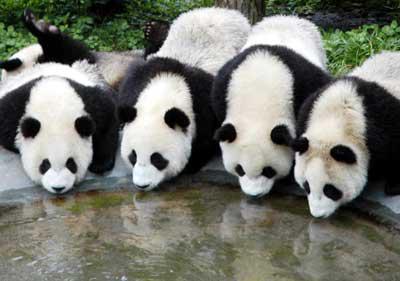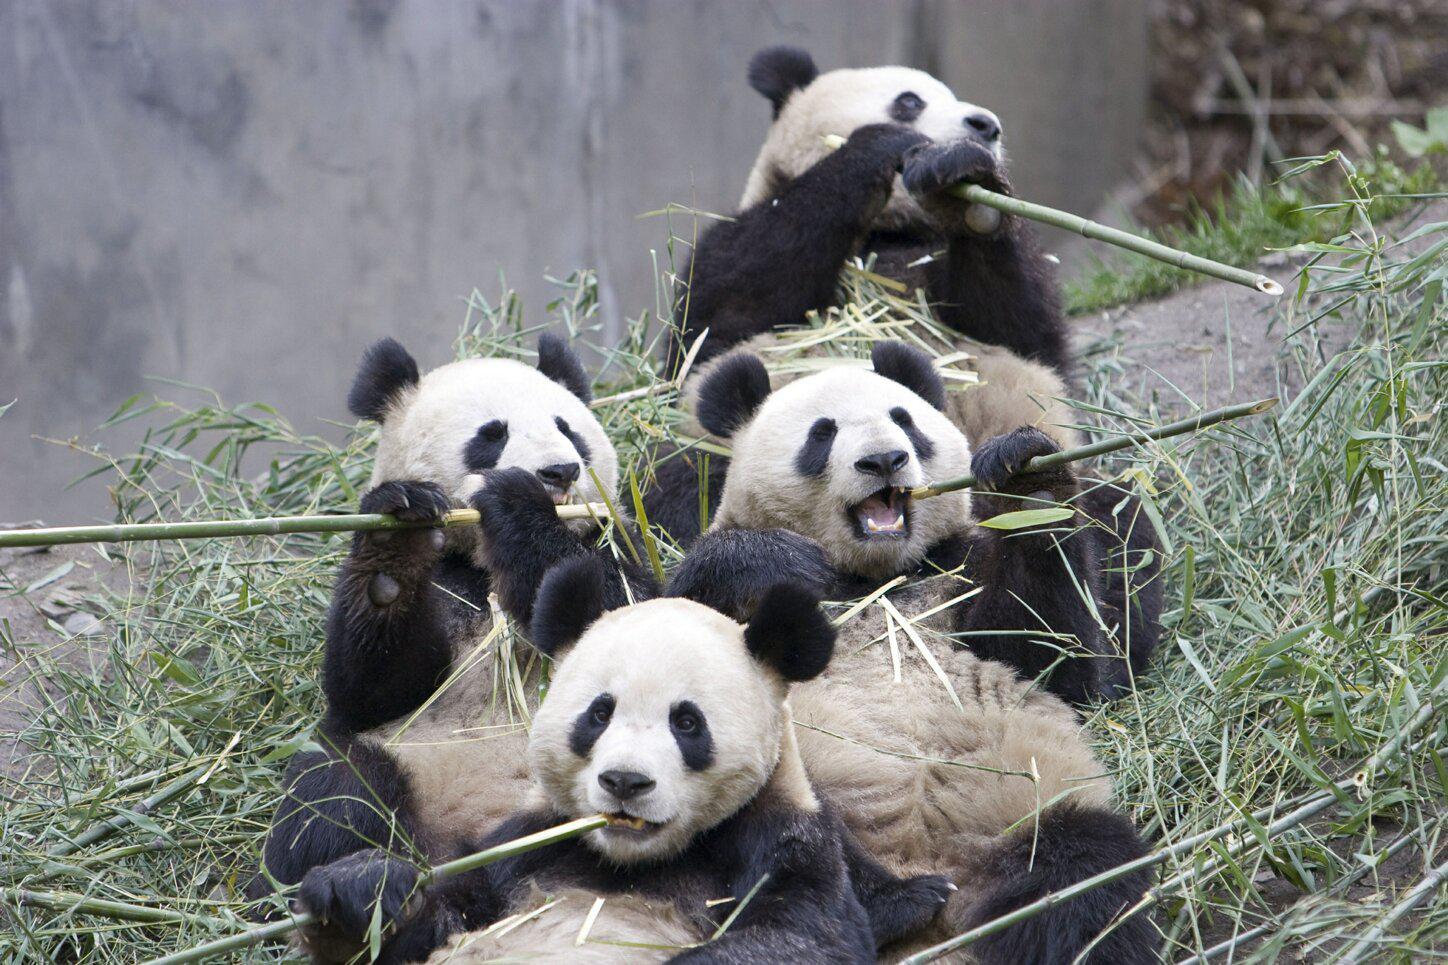The first image is the image on the left, the second image is the image on the right. Assess this claim about the two images: "A giant panda is frolicking outside.". Correct or not? Answer yes or no. No. The first image is the image on the left, the second image is the image on the right. Analyze the images presented: Is the assertion "The panda in the image to the left is alone." valid? Answer yes or no. No. 